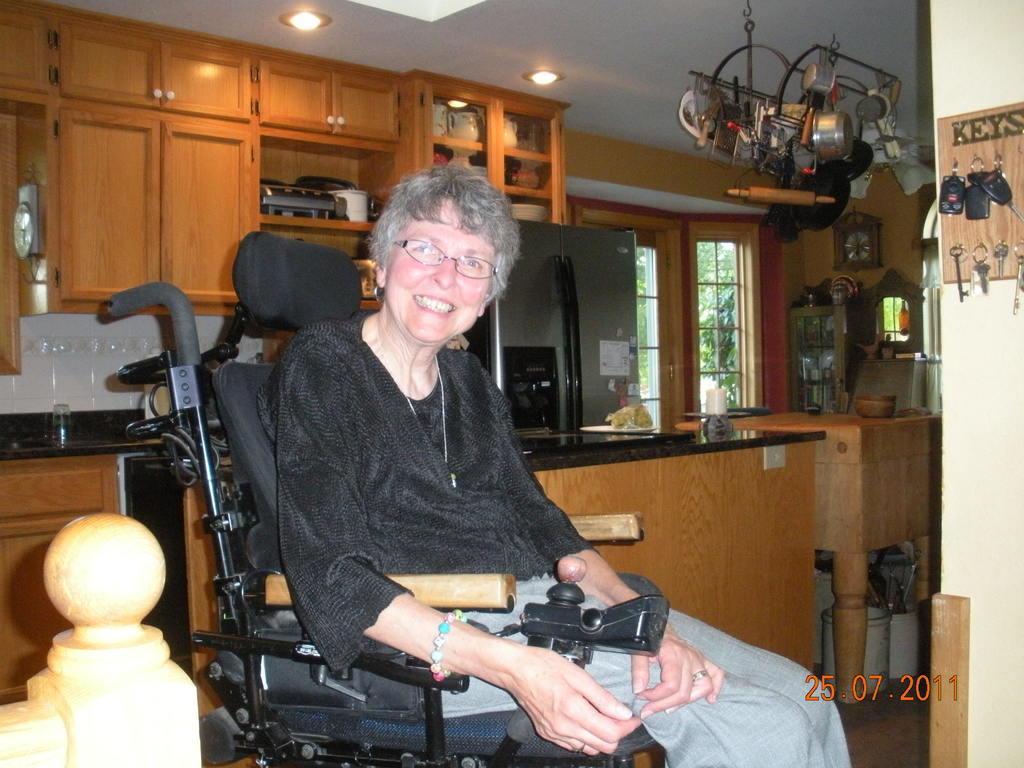Can you describe this image briefly? There is one woman sitting in a wheel chair as we can see at the bottom of this image. There is a window, cupboard and other objects are present in the background. There is a watermark in the bottom right corner of this image. We can see keys on the right side of this image. 